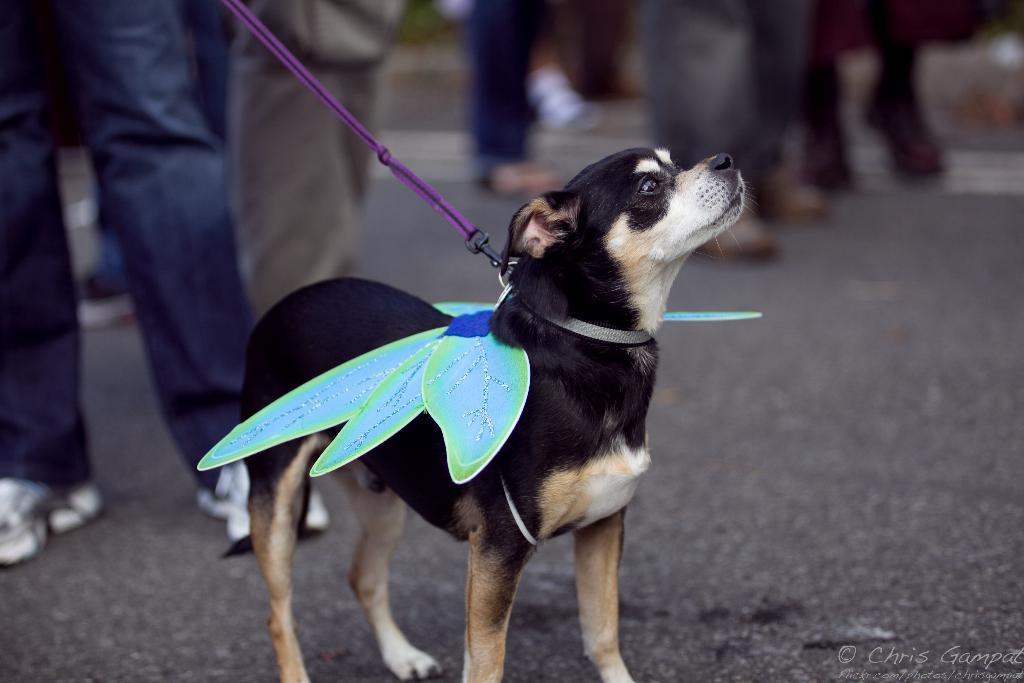In one or two sentences, can you explain what this image depicts? In the image we can see there is a dog standing on the road and wearing wings. A person is holding the rope of the dog's neck and behind the image is little blurry. 